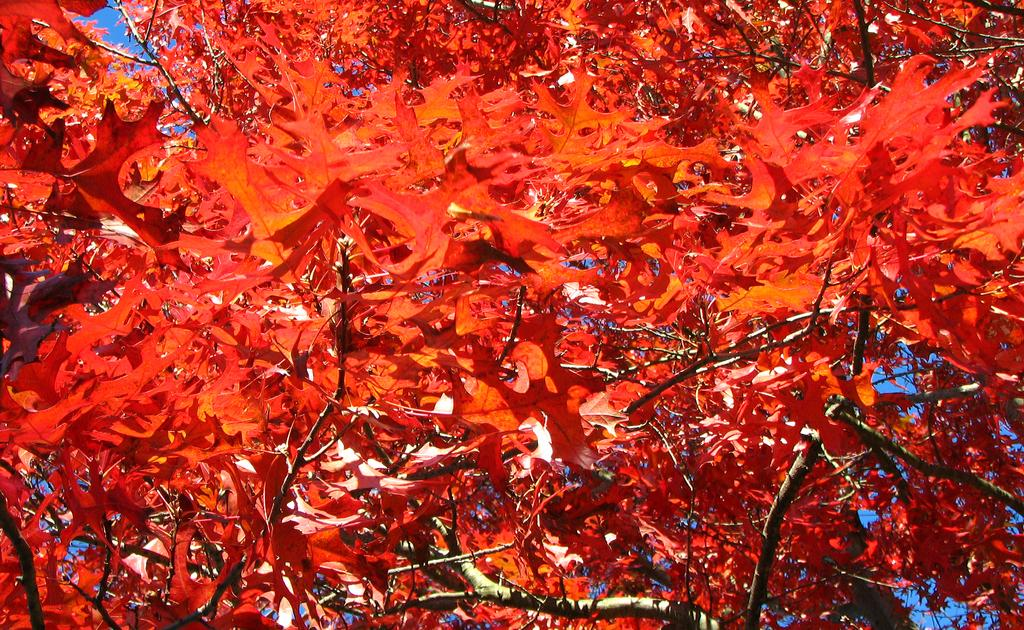What color are the leaves on the tree in the image? The leaves on the tree in the image are red. How many leaves can be seen on the tree? The image shows many red leaves on the tree. What season might the image represent based on the color of the leaves? The red leaves on the tree suggest that the image might represent the fall season. What memory does the tree in the image hold? The image does not convey any specific memory associated with the tree. Is there a ghost visible in the image? There is no ghost present in the image. 